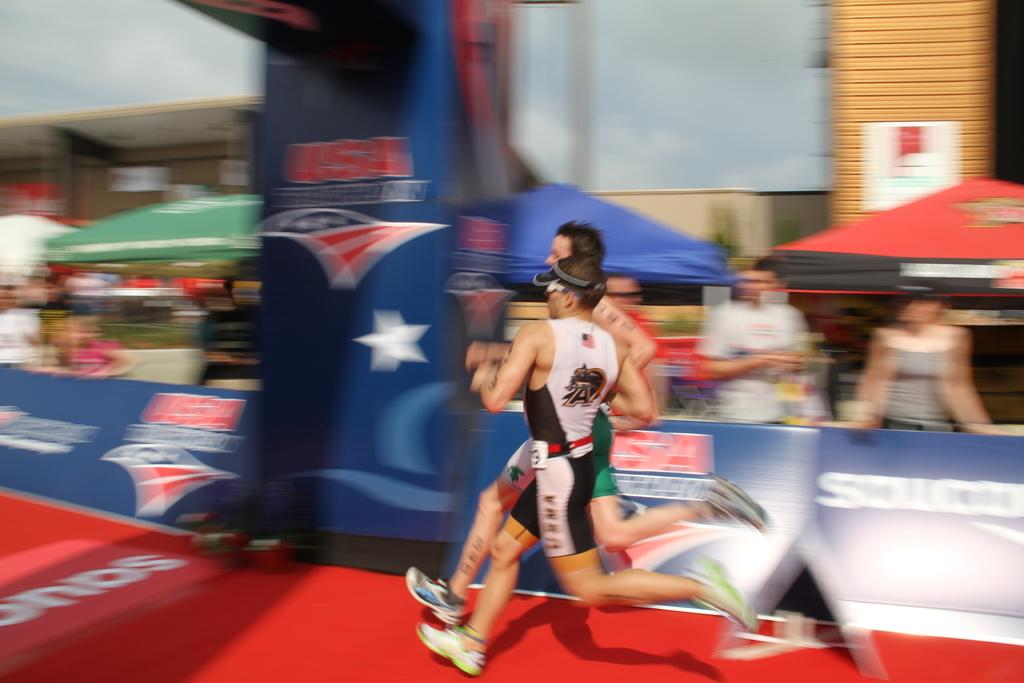How many athletes are in the image? There are two athletes in the image. What are the athletes doing in the image? The athletes are running on a red surface. What is the quality of the image? The image is blurred. When was the picture taken? The picture was taken while the athletes were running. Are there any other people present in the image? Yes, there are people around the athletes. What else can be seen in the image besides the athletes and people? There are banners in the image. What type of can is visible in the image? There is no can present in the image. What station are the athletes running towards in the image? The image does not show a station or any indication of a destination for the athletes. 